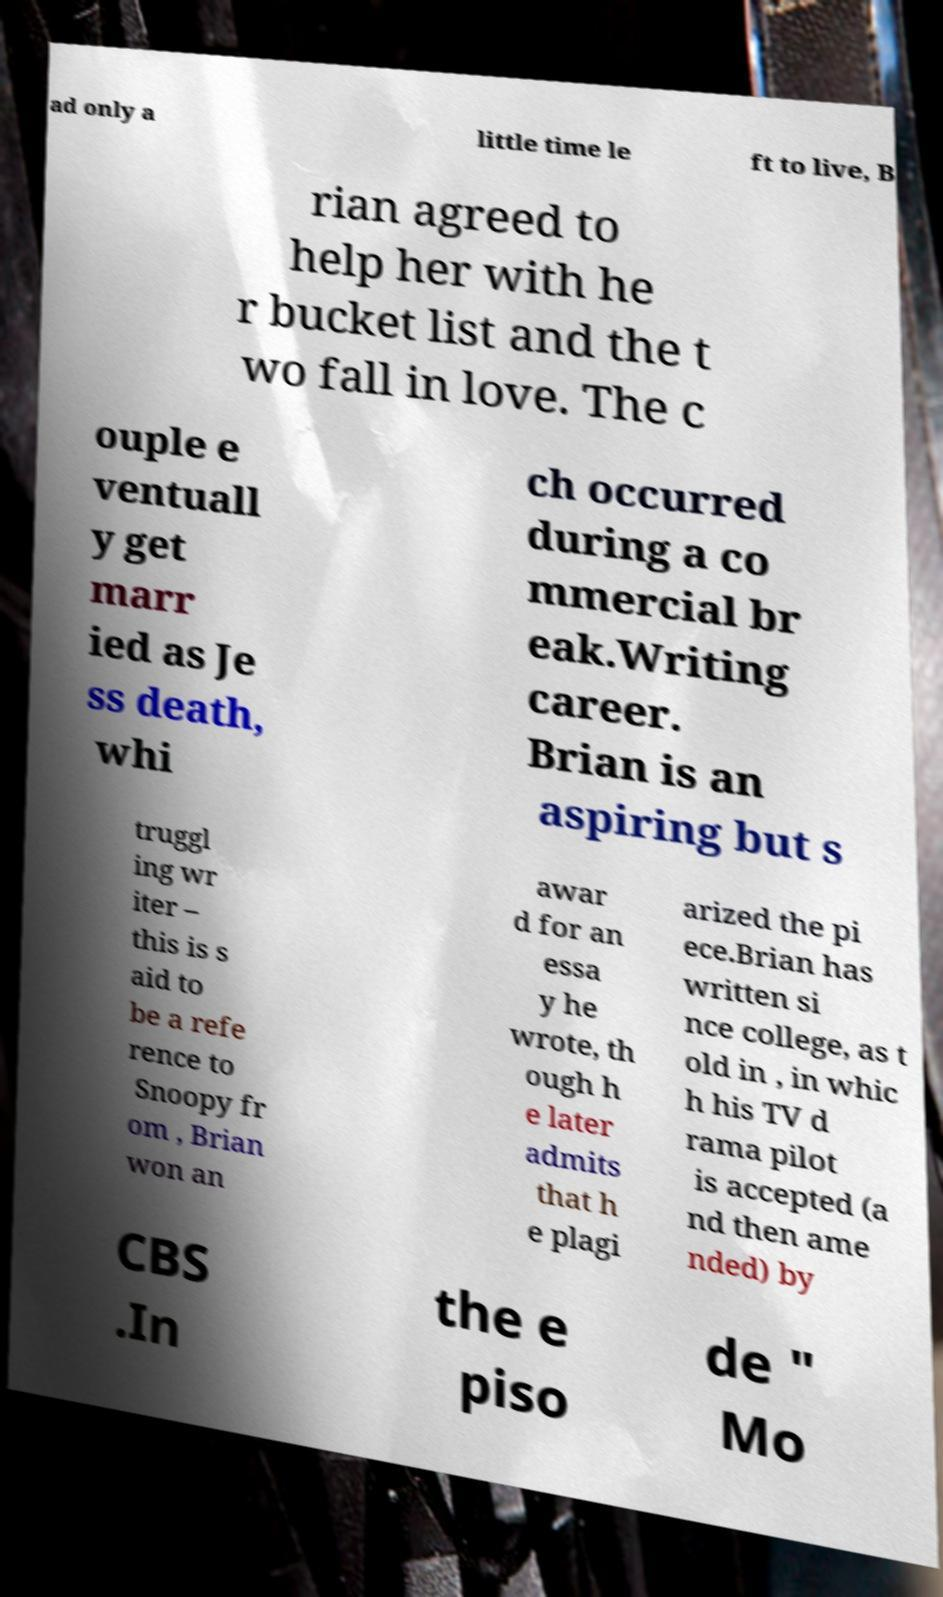Can you accurately transcribe the text from the provided image for me? ad only a little time le ft to live, B rian agreed to help her with he r bucket list and the t wo fall in love. The c ouple e ventuall y get marr ied as Je ss death, whi ch occurred during a co mmercial br eak.Writing career. Brian is an aspiring but s truggl ing wr iter – this is s aid to be a refe rence to Snoopy fr om , Brian won an awar d for an essa y he wrote, th ough h e later admits that h e plagi arized the pi ece.Brian has written si nce college, as t old in , in whic h his TV d rama pilot is accepted (a nd then ame nded) by CBS .In the e piso de " Mo 